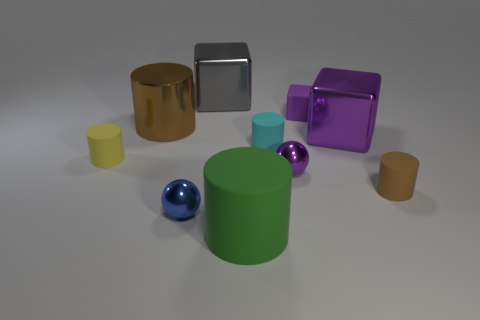Subtract all large green cylinders. How many cylinders are left? 4 Subtract all cyan cylinders. How many cylinders are left? 4 Subtract 1 cylinders. How many cylinders are left? 4 Subtract all purple cylinders. Subtract all yellow balls. How many cylinders are left? 5 Subtract all cubes. How many objects are left? 7 Add 4 big brown shiny cylinders. How many big brown shiny cylinders exist? 5 Subtract 0 gray cylinders. How many objects are left? 10 Subtract all purple rubber cylinders. Subtract all metal blocks. How many objects are left? 8 Add 6 blue metal objects. How many blue metal objects are left? 7 